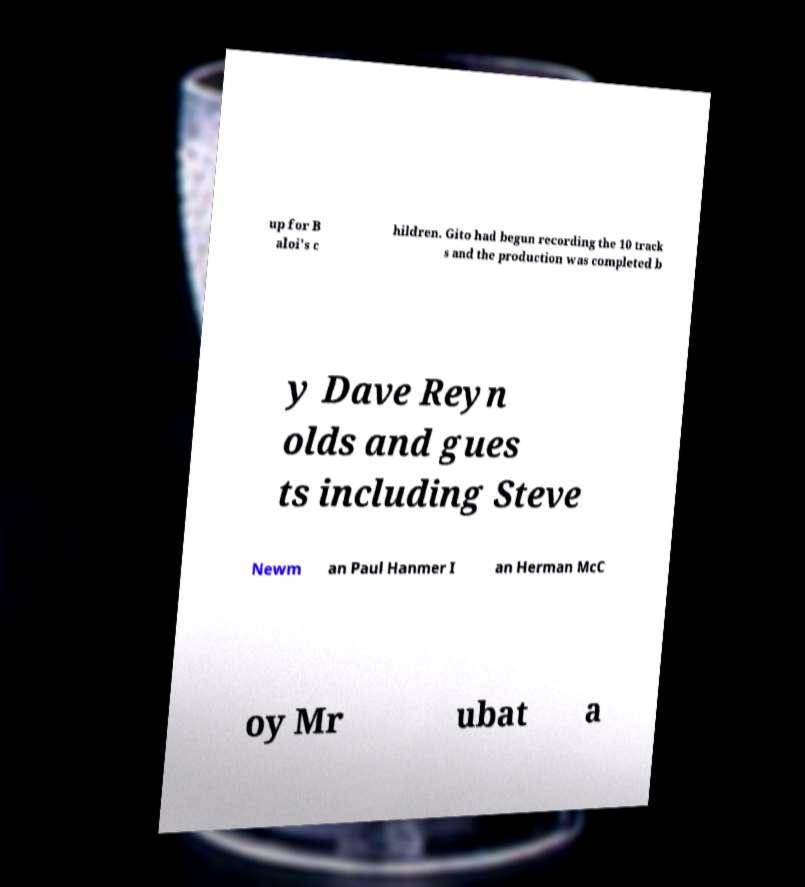For documentation purposes, I need the text within this image transcribed. Could you provide that? up for B aloi's c hildren. Gito had begun recording the 10 track s and the production was completed b y Dave Reyn olds and gues ts including Steve Newm an Paul Hanmer I an Herman McC oy Mr ubat a 